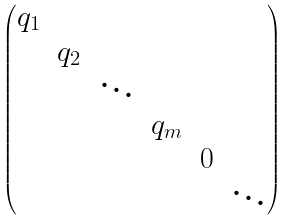Convert formula to latex. <formula><loc_0><loc_0><loc_500><loc_500>\begin{pmatrix} q _ { 1 } \\ & q _ { 2 } \\ & & \ddots \\ & & & q _ { m } \\ & & & & 0 \\ & & & & & \ddots \end{pmatrix}</formula> 